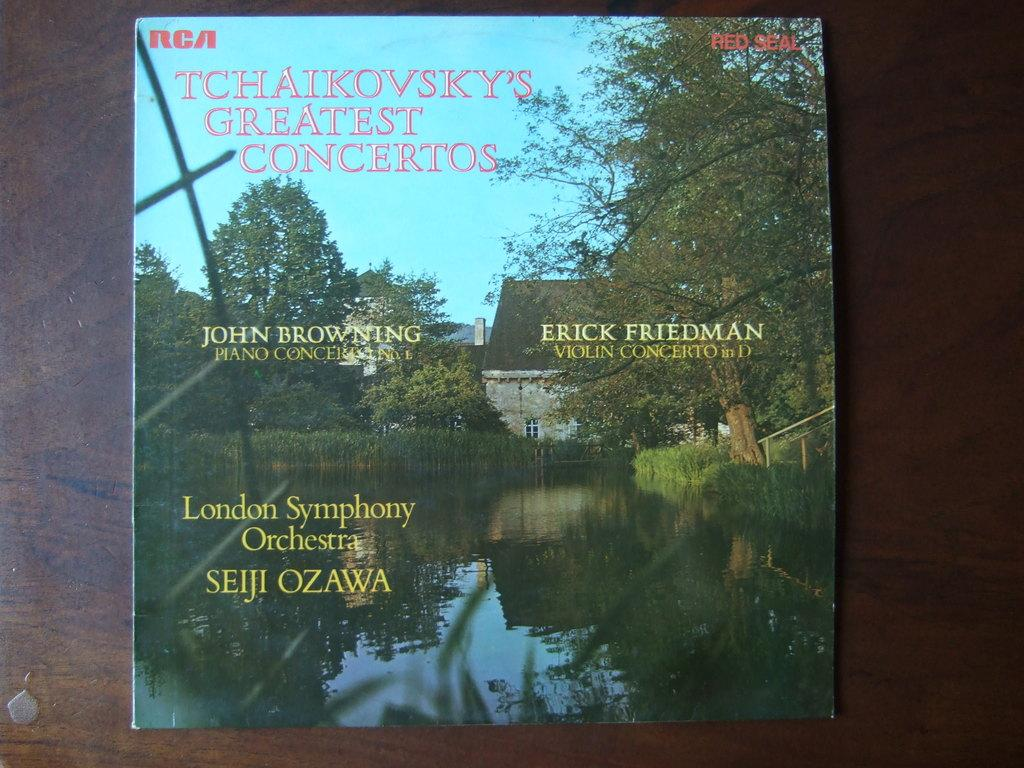<image>
Relay a brief, clear account of the picture shown. Album cover for "Tchaikovsky's Greatest Concerts" showing a house by a river and trees. 